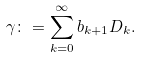<formula> <loc_0><loc_0><loc_500><loc_500>\gamma \colon = \sum _ { k = 0 } ^ { \infty } b _ { k + 1 } D _ { k } .</formula> 